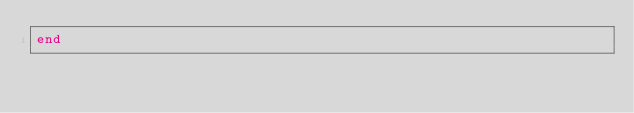<code> <loc_0><loc_0><loc_500><loc_500><_Ruby_>end
</code> 